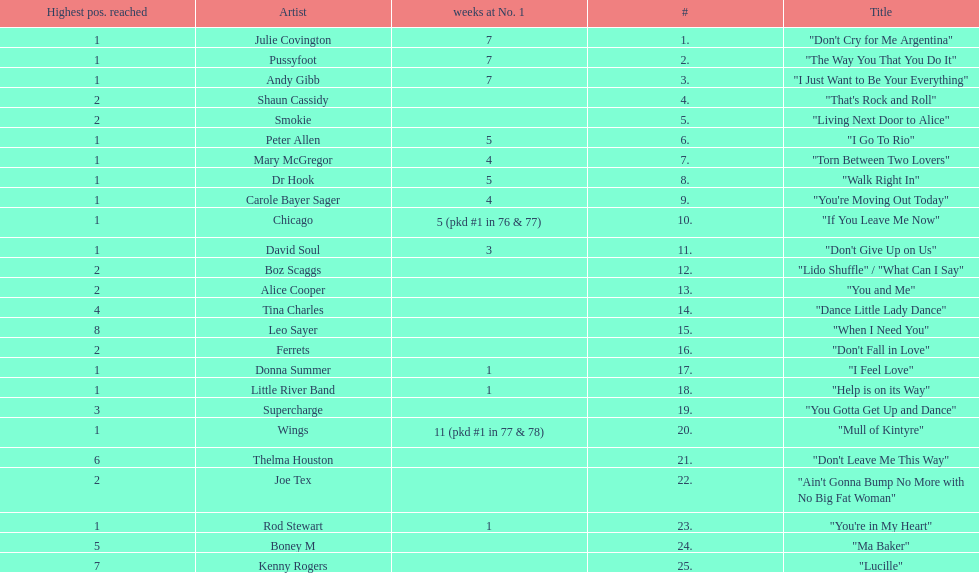Who had the most weeks at number one, according to the table? Wings. Parse the table in full. {'header': ['Highest pos. reached', 'Artist', 'weeks at No. 1', '#', 'Title'], 'rows': [['1', 'Julie Covington', '7', '1.', '"Don\'t Cry for Me Argentina"'], ['1', 'Pussyfoot', '7', '2.', '"The Way You That You Do It"'], ['1', 'Andy Gibb', '7', '3.', '"I Just Want to Be Your Everything"'], ['2', 'Shaun Cassidy', '', '4.', '"That\'s Rock and Roll"'], ['2', 'Smokie', '', '5.', '"Living Next Door to Alice"'], ['1', 'Peter Allen', '5', '6.', '"I Go To Rio"'], ['1', 'Mary McGregor', '4', '7.', '"Torn Between Two Lovers"'], ['1', 'Dr Hook', '5', '8.', '"Walk Right In"'], ['1', 'Carole Bayer Sager', '4', '9.', '"You\'re Moving Out Today"'], ['1', 'Chicago', '5 (pkd #1 in 76 & 77)', '10.', '"If You Leave Me Now"'], ['1', 'David Soul', '3', '11.', '"Don\'t Give Up on Us"'], ['2', 'Boz Scaggs', '', '12.', '"Lido Shuffle" / "What Can I Say"'], ['2', 'Alice Cooper', '', '13.', '"You and Me"'], ['4', 'Tina Charles', '', '14.', '"Dance Little Lady Dance"'], ['8', 'Leo Sayer', '', '15.', '"When I Need You"'], ['2', 'Ferrets', '', '16.', '"Don\'t Fall in Love"'], ['1', 'Donna Summer', '1', '17.', '"I Feel Love"'], ['1', 'Little River Band', '1', '18.', '"Help is on its Way"'], ['3', 'Supercharge', '', '19.', '"You Gotta Get Up and Dance"'], ['1', 'Wings', '11 (pkd #1 in 77 & 78)', '20.', '"Mull of Kintyre"'], ['6', 'Thelma Houston', '', '21.', '"Don\'t Leave Me This Way"'], ['2', 'Joe Tex', '', '22.', '"Ain\'t Gonna Bump No More with No Big Fat Woman"'], ['1', 'Rod Stewart', '1', '23.', '"You\'re in My Heart"'], ['5', 'Boney M', '', '24.', '"Ma Baker"'], ['7', 'Kenny Rogers', '', '25.', '"Lucille"']]} 